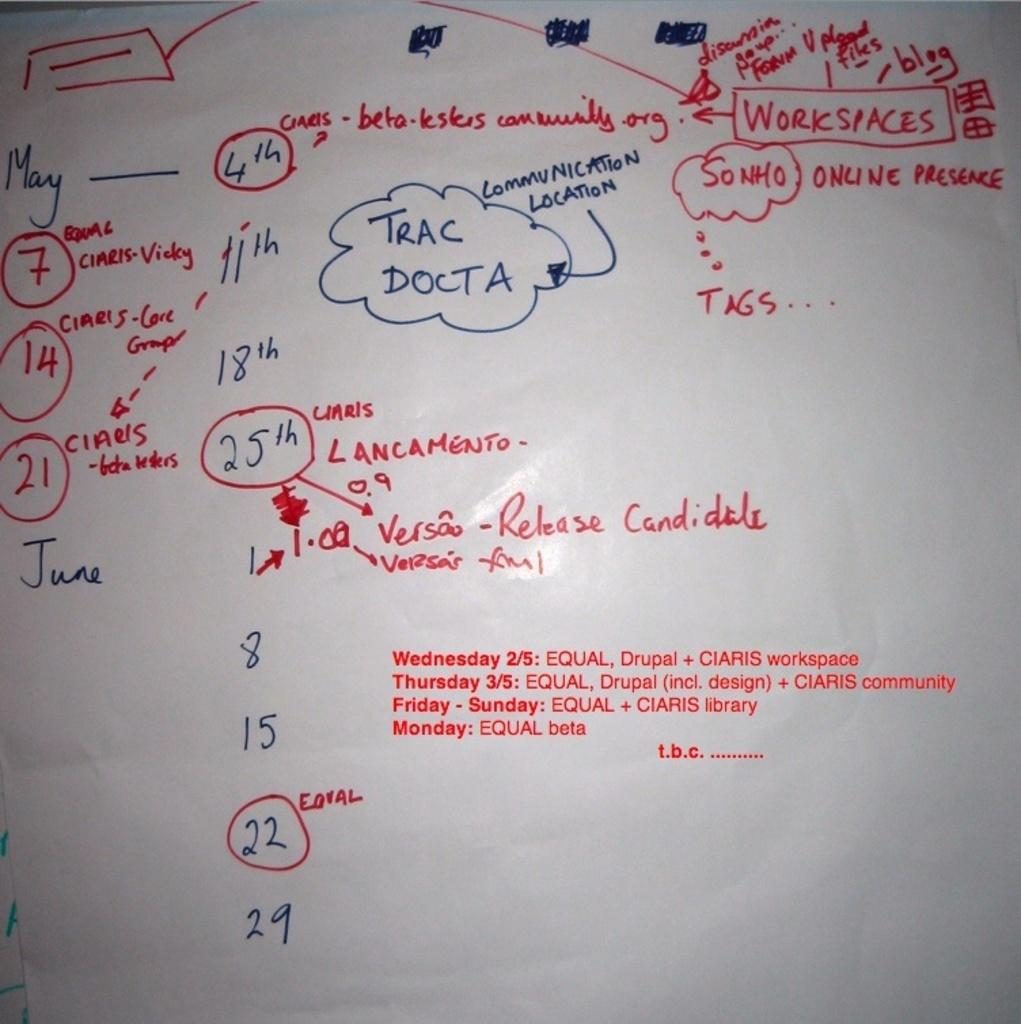<image>
Present a compact description of the photo's key features. a whiteboard has a map starting with workspaces is at the right top corner 